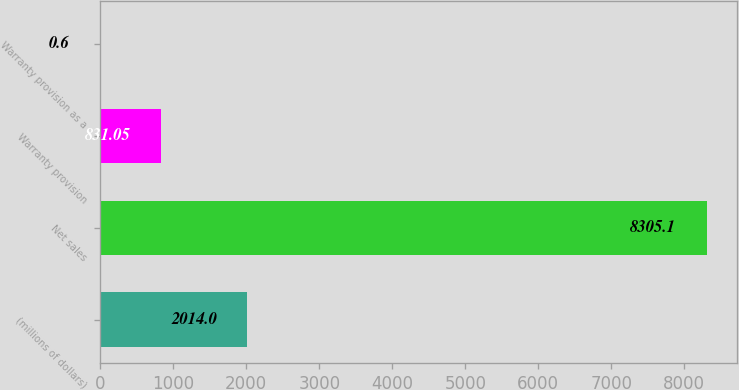Convert chart to OTSL. <chart><loc_0><loc_0><loc_500><loc_500><bar_chart><fcel>(millions of dollars)<fcel>Net sales<fcel>Warranty provision<fcel>Warranty provision as a<nl><fcel>2014<fcel>8305.1<fcel>831.05<fcel>0.6<nl></chart> 